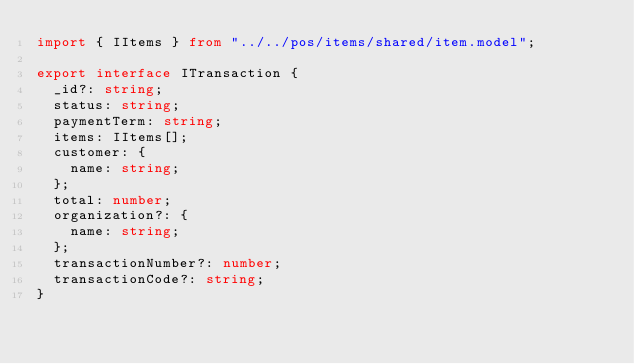<code> <loc_0><loc_0><loc_500><loc_500><_TypeScript_>import { IItems } from "../../pos/items/shared/item.model";

export interface ITransaction {
  _id?: string;
  status: string;
  paymentTerm: string;
  items: IItems[];
  customer: {
    name: string;
  };
  total: number;
  organization?: {
    name: string;
  };
  transactionNumber?: number;
  transactionCode?: string;
}
</code> 